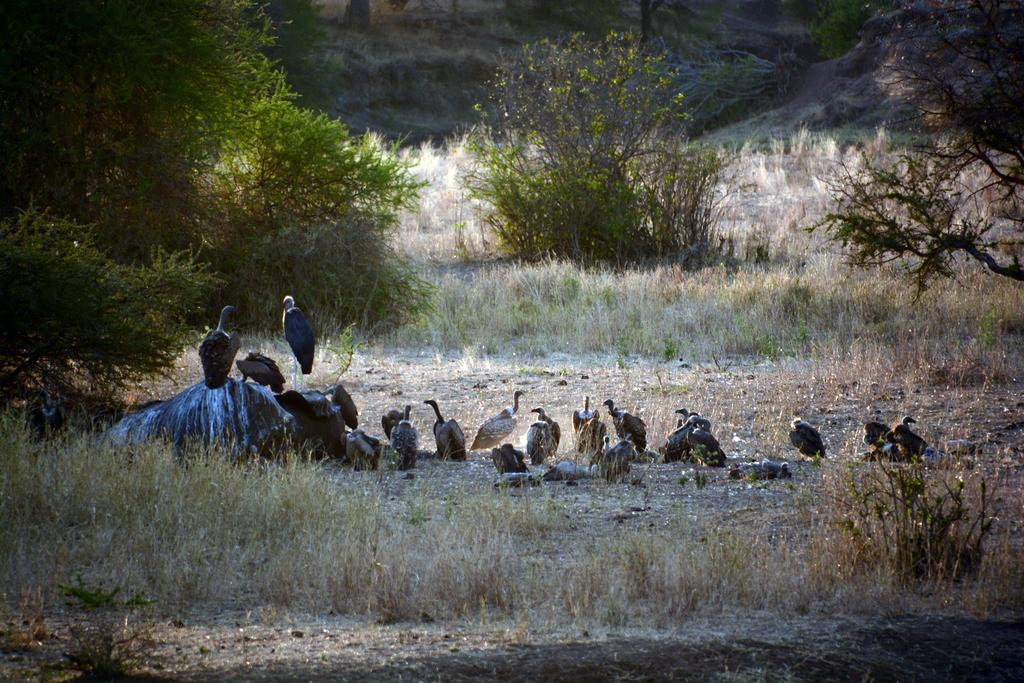What type of surface is visible in the image? There is a surface with dried grass in the image. What animals are standing on the surface? There are vultures standing on the surface. Are there any vultures standing around the surface as well? Yes, the vultures are also standing around the surface. What type of vegetation can be seen in the image? There are plants visible in the image. What type of cactus can be seen in the image? There is no cactus present in the image; it features a surface with dried grass and vultures. What hope does the image convey? The image does not convey any specific hope or message; it is a visual representation of a surface with dried grass and vultures. 